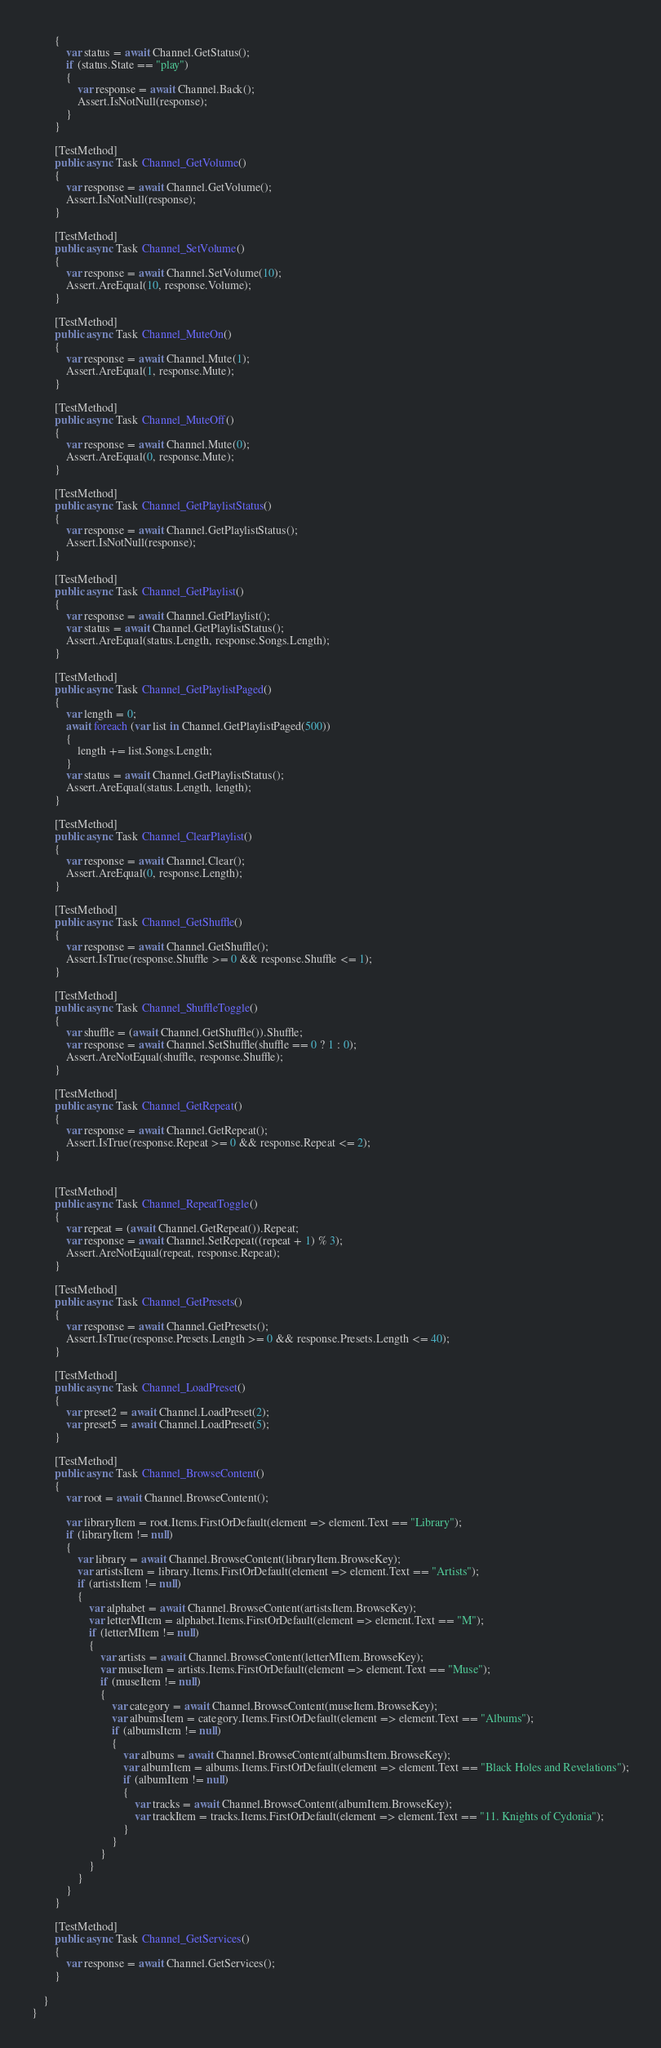<code> <loc_0><loc_0><loc_500><loc_500><_C#_>        {
            var status = await Channel.GetStatus();
            if (status.State == "play")
            {
                var response = await Channel.Back();
                Assert.IsNotNull(response);
            }
        }

        [TestMethod]
        public async Task Channel_GetVolume()
        {
            var response = await Channel.GetVolume();
            Assert.IsNotNull(response);
        }

        [TestMethod]
        public async Task Channel_SetVolume()
        {
            var response = await Channel.SetVolume(10);
            Assert.AreEqual(10, response.Volume);
        }

        [TestMethod]
        public async Task Channel_MuteOn()
        {
            var response = await Channel.Mute(1);
            Assert.AreEqual(1, response.Mute);
        }

        [TestMethod]
        public async Task Channel_MuteOff()
        {
            var response = await Channel.Mute(0);
            Assert.AreEqual(0, response.Mute);
        }

        [TestMethod]
        public async Task Channel_GetPlaylistStatus()
        {
            var response = await Channel.GetPlaylistStatus();
            Assert.IsNotNull(response);
        }

        [TestMethod]
        public async Task Channel_GetPlaylist()
        {
            var response = await Channel.GetPlaylist();
            var status = await Channel.GetPlaylistStatus();
            Assert.AreEqual(status.Length, response.Songs.Length);
        }

        [TestMethod]
        public async Task Channel_GetPlaylistPaged()
        {
            var length = 0;
            await foreach (var list in Channel.GetPlaylistPaged(500))
            {
                length += list.Songs.Length;
            }
            var status = await Channel.GetPlaylistStatus();
            Assert.AreEqual(status.Length, length);
        }

        [TestMethod]
        public async Task Channel_ClearPlaylist()
        {
            var response = await Channel.Clear();
            Assert.AreEqual(0, response.Length);
        }

        [TestMethod]
        public async Task Channel_GetShuffle()
        {
            var response = await Channel.GetShuffle();
            Assert.IsTrue(response.Shuffle >= 0 && response.Shuffle <= 1);
        }

        [TestMethod]
        public async Task Channel_ShuffleToggle()
        {
            var shuffle = (await Channel.GetShuffle()).Shuffle;
            var response = await Channel.SetShuffle(shuffle == 0 ? 1 : 0);
            Assert.AreNotEqual(shuffle, response.Shuffle);
        }

        [TestMethod]
        public async Task Channel_GetRepeat()
        {
            var response = await Channel.GetRepeat();
            Assert.IsTrue(response.Repeat >= 0 && response.Repeat <= 2);
        }


        [TestMethod]
        public async Task Channel_RepeatToggle()
        {
            var repeat = (await Channel.GetRepeat()).Repeat;
            var response = await Channel.SetRepeat((repeat + 1) % 3);
            Assert.AreNotEqual(repeat, response.Repeat);
        }

        [TestMethod]
        public async Task Channel_GetPresets()
        {
            var response = await Channel.GetPresets();
            Assert.IsTrue(response.Presets.Length >= 0 && response.Presets.Length <= 40);
        }

        [TestMethod]
        public async Task Channel_LoadPreset()
        {
            var preset2 = await Channel.LoadPreset(2);
            var preset5 = await Channel.LoadPreset(5);
        }

        [TestMethod]
        public async Task Channel_BrowseContent()
        {
            var root = await Channel.BrowseContent();

            var libraryItem = root.Items.FirstOrDefault(element => element.Text == "Library");
            if (libraryItem != null)
            {
                var library = await Channel.BrowseContent(libraryItem.BrowseKey);
                var artistsItem = library.Items.FirstOrDefault(element => element.Text == "Artists");
                if (artistsItem != null)
                {
                    var alphabet = await Channel.BrowseContent(artistsItem.BrowseKey);
                    var letterMItem = alphabet.Items.FirstOrDefault(element => element.Text == "M");
                    if (letterMItem != null)
                    {
                        var artists = await Channel.BrowseContent(letterMItem.BrowseKey);
                        var museItem = artists.Items.FirstOrDefault(element => element.Text == "Muse");
                        if (museItem != null)
                        {
                            var category = await Channel.BrowseContent(museItem.BrowseKey);
                            var albumsItem = category.Items.FirstOrDefault(element => element.Text == "Albums");
                            if (albumsItem != null)
                            {
                                var albums = await Channel.BrowseContent(albumsItem.BrowseKey);
                                var albumItem = albums.Items.FirstOrDefault(element => element.Text == "Black Holes and Revelations");
                                if (albumItem != null)
                                {
                                    var tracks = await Channel.BrowseContent(albumItem.BrowseKey);
                                    var trackItem = tracks.Items.FirstOrDefault(element => element.Text == "11. Knights of Cydonia");
                                }
                            }
                        }
                    }
                }
            }
        }

        [TestMethod]
        public async Task Channel_GetServices()
        {
            var response = await Channel.GetServices();
        }

    }
}
</code> 